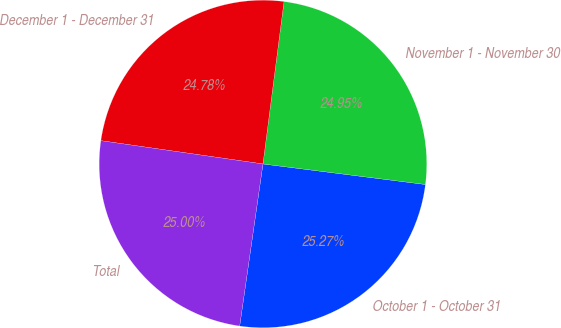<chart> <loc_0><loc_0><loc_500><loc_500><pie_chart><fcel>October 1 - October 31<fcel>November 1 - November 30<fcel>December 1 - December 31<fcel>Total<nl><fcel>25.27%<fcel>24.95%<fcel>24.78%<fcel>25.0%<nl></chart> 